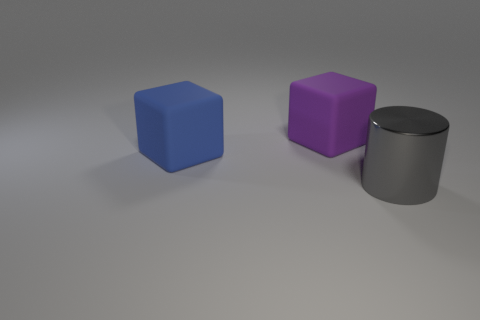Add 3 red shiny cubes. How many objects exist? 6 Subtract all cylinders. How many objects are left? 2 Add 1 big gray metallic cylinders. How many big gray metallic cylinders exist? 2 Subtract 0 green blocks. How many objects are left? 3 Subtract all big things. Subtract all large cyan shiny blocks. How many objects are left? 0 Add 2 purple objects. How many purple objects are left? 3 